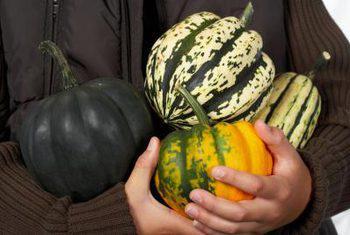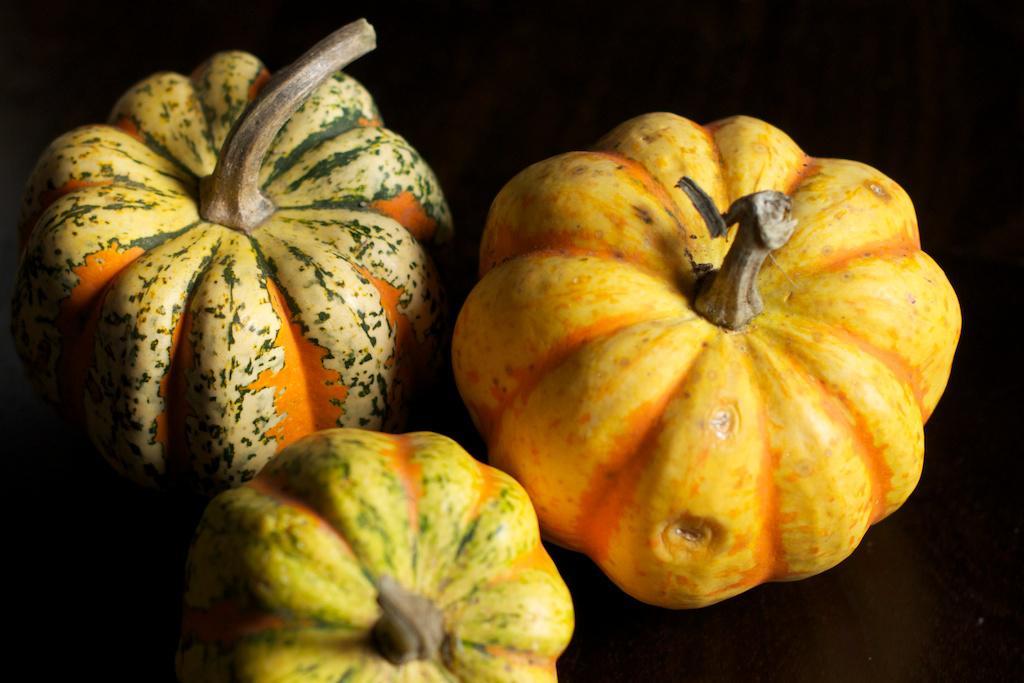The first image is the image on the left, the second image is the image on the right. Analyze the images presented: Is the assertion "There are fewer than ten squashes." valid? Answer yes or no. Yes. The first image is the image on the left, the second image is the image on the right. Assess this claim about the two images: "The left image includes multiple squash with yellow tops and green variegated bottoms and does not include any solid colored squash.". Correct or not? Answer yes or no. No. 